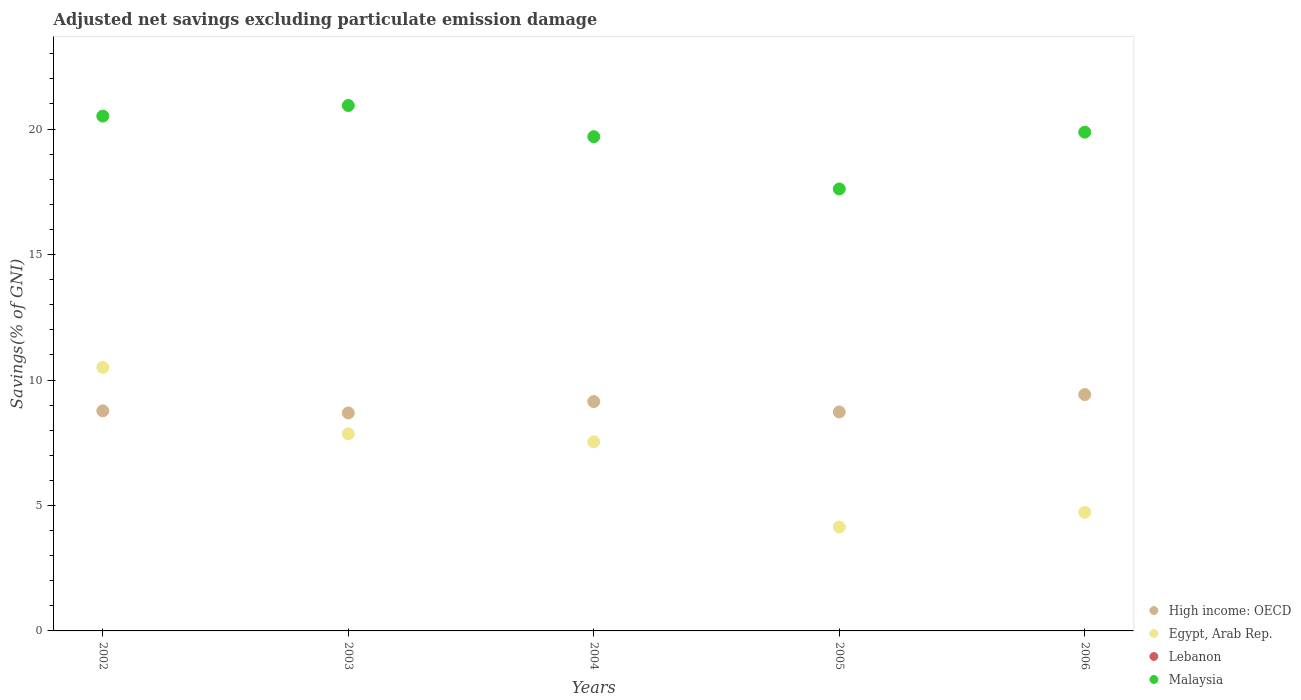How many different coloured dotlines are there?
Your response must be concise. 3. Is the number of dotlines equal to the number of legend labels?
Your answer should be very brief. No. What is the adjusted net savings in High income: OECD in 2006?
Offer a terse response. 9.42. Across all years, what is the maximum adjusted net savings in Malaysia?
Your answer should be compact. 20.94. Across all years, what is the minimum adjusted net savings in High income: OECD?
Give a very brief answer. 8.69. In which year was the adjusted net savings in High income: OECD maximum?
Offer a very short reply. 2006. What is the total adjusted net savings in Egypt, Arab Rep. in the graph?
Keep it short and to the point. 34.76. What is the difference between the adjusted net savings in Malaysia in 2004 and that in 2006?
Offer a very short reply. -0.18. What is the difference between the adjusted net savings in Egypt, Arab Rep. in 2003 and the adjusted net savings in High income: OECD in 2005?
Offer a very short reply. -0.87. What is the average adjusted net savings in High income: OECD per year?
Provide a short and direct response. 8.95. In the year 2006, what is the difference between the adjusted net savings in Egypt, Arab Rep. and adjusted net savings in Malaysia?
Offer a terse response. -15.15. What is the ratio of the adjusted net savings in Malaysia in 2005 to that in 2006?
Make the answer very short. 0.89. What is the difference between the highest and the second highest adjusted net savings in Malaysia?
Keep it short and to the point. 0.42. What is the difference between the highest and the lowest adjusted net savings in Malaysia?
Keep it short and to the point. 3.33. Is it the case that in every year, the sum of the adjusted net savings in Malaysia and adjusted net savings in High income: OECD  is greater than the adjusted net savings in Egypt, Arab Rep.?
Give a very brief answer. Yes. Does the adjusted net savings in Egypt, Arab Rep. monotonically increase over the years?
Provide a short and direct response. No. Is the adjusted net savings in Egypt, Arab Rep. strictly less than the adjusted net savings in High income: OECD over the years?
Offer a terse response. No. Are the values on the major ticks of Y-axis written in scientific E-notation?
Offer a terse response. No. Does the graph contain any zero values?
Ensure brevity in your answer.  Yes. How many legend labels are there?
Your answer should be very brief. 4. How are the legend labels stacked?
Provide a succinct answer. Vertical. What is the title of the graph?
Your response must be concise. Adjusted net savings excluding particulate emission damage. What is the label or title of the Y-axis?
Your response must be concise. Savings(% of GNI). What is the Savings(% of GNI) of High income: OECD in 2002?
Keep it short and to the point. 8.77. What is the Savings(% of GNI) in Egypt, Arab Rep. in 2002?
Make the answer very short. 10.5. What is the Savings(% of GNI) in Lebanon in 2002?
Give a very brief answer. 0. What is the Savings(% of GNI) in Malaysia in 2002?
Your response must be concise. 20.52. What is the Savings(% of GNI) of High income: OECD in 2003?
Make the answer very short. 8.69. What is the Savings(% of GNI) in Egypt, Arab Rep. in 2003?
Keep it short and to the point. 7.86. What is the Savings(% of GNI) in Malaysia in 2003?
Ensure brevity in your answer.  20.94. What is the Savings(% of GNI) of High income: OECD in 2004?
Give a very brief answer. 9.14. What is the Savings(% of GNI) of Egypt, Arab Rep. in 2004?
Your response must be concise. 7.54. What is the Savings(% of GNI) in Lebanon in 2004?
Provide a succinct answer. 0. What is the Savings(% of GNI) in Malaysia in 2004?
Keep it short and to the point. 19.7. What is the Savings(% of GNI) of High income: OECD in 2005?
Make the answer very short. 8.73. What is the Savings(% of GNI) in Egypt, Arab Rep. in 2005?
Ensure brevity in your answer.  4.14. What is the Savings(% of GNI) in Malaysia in 2005?
Offer a terse response. 17.61. What is the Savings(% of GNI) in High income: OECD in 2006?
Make the answer very short. 9.42. What is the Savings(% of GNI) of Egypt, Arab Rep. in 2006?
Keep it short and to the point. 4.73. What is the Savings(% of GNI) of Lebanon in 2006?
Your answer should be compact. 0. What is the Savings(% of GNI) of Malaysia in 2006?
Your answer should be compact. 19.88. Across all years, what is the maximum Savings(% of GNI) of High income: OECD?
Offer a terse response. 9.42. Across all years, what is the maximum Savings(% of GNI) in Egypt, Arab Rep.?
Ensure brevity in your answer.  10.5. Across all years, what is the maximum Savings(% of GNI) of Malaysia?
Provide a short and direct response. 20.94. Across all years, what is the minimum Savings(% of GNI) in High income: OECD?
Offer a terse response. 8.69. Across all years, what is the minimum Savings(% of GNI) of Egypt, Arab Rep.?
Give a very brief answer. 4.14. Across all years, what is the minimum Savings(% of GNI) in Malaysia?
Offer a terse response. 17.61. What is the total Savings(% of GNI) of High income: OECD in the graph?
Offer a terse response. 44.75. What is the total Savings(% of GNI) in Egypt, Arab Rep. in the graph?
Provide a short and direct response. 34.76. What is the total Savings(% of GNI) in Lebanon in the graph?
Ensure brevity in your answer.  0. What is the total Savings(% of GNI) of Malaysia in the graph?
Your answer should be very brief. 98.65. What is the difference between the Savings(% of GNI) in High income: OECD in 2002 and that in 2003?
Make the answer very short. 0.08. What is the difference between the Savings(% of GNI) of Egypt, Arab Rep. in 2002 and that in 2003?
Make the answer very short. 2.65. What is the difference between the Savings(% of GNI) of Malaysia in 2002 and that in 2003?
Keep it short and to the point. -0.42. What is the difference between the Savings(% of GNI) of High income: OECD in 2002 and that in 2004?
Ensure brevity in your answer.  -0.37. What is the difference between the Savings(% of GNI) of Egypt, Arab Rep. in 2002 and that in 2004?
Give a very brief answer. 2.97. What is the difference between the Savings(% of GNI) of Malaysia in 2002 and that in 2004?
Offer a terse response. 0.82. What is the difference between the Savings(% of GNI) of High income: OECD in 2002 and that in 2005?
Your response must be concise. 0.04. What is the difference between the Savings(% of GNI) of Egypt, Arab Rep. in 2002 and that in 2005?
Offer a very short reply. 6.36. What is the difference between the Savings(% of GNI) in Malaysia in 2002 and that in 2005?
Your response must be concise. 2.9. What is the difference between the Savings(% of GNI) in High income: OECD in 2002 and that in 2006?
Your answer should be compact. -0.65. What is the difference between the Savings(% of GNI) in Egypt, Arab Rep. in 2002 and that in 2006?
Your response must be concise. 5.77. What is the difference between the Savings(% of GNI) of Malaysia in 2002 and that in 2006?
Keep it short and to the point. 0.64. What is the difference between the Savings(% of GNI) of High income: OECD in 2003 and that in 2004?
Your response must be concise. -0.45. What is the difference between the Savings(% of GNI) of Egypt, Arab Rep. in 2003 and that in 2004?
Keep it short and to the point. 0.32. What is the difference between the Savings(% of GNI) in Malaysia in 2003 and that in 2004?
Offer a terse response. 1.24. What is the difference between the Savings(% of GNI) in High income: OECD in 2003 and that in 2005?
Your response must be concise. -0.04. What is the difference between the Savings(% of GNI) of Egypt, Arab Rep. in 2003 and that in 2005?
Offer a very short reply. 3.72. What is the difference between the Savings(% of GNI) in Malaysia in 2003 and that in 2005?
Offer a terse response. 3.33. What is the difference between the Savings(% of GNI) of High income: OECD in 2003 and that in 2006?
Provide a succinct answer. -0.73. What is the difference between the Savings(% of GNI) of Egypt, Arab Rep. in 2003 and that in 2006?
Provide a short and direct response. 3.13. What is the difference between the Savings(% of GNI) in Malaysia in 2003 and that in 2006?
Provide a succinct answer. 1.06. What is the difference between the Savings(% of GNI) of High income: OECD in 2004 and that in 2005?
Ensure brevity in your answer.  0.41. What is the difference between the Savings(% of GNI) of Egypt, Arab Rep. in 2004 and that in 2005?
Keep it short and to the point. 3.4. What is the difference between the Savings(% of GNI) in Malaysia in 2004 and that in 2005?
Your response must be concise. 2.08. What is the difference between the Savings(% of GNI) of High income: OECD in 2004 and that in 2006?
Offer a terse response. -0.28. What is the difference between the Savings(% of GNI) in Egypt, Arab Rep. in 2004 and that in 2006?
Offer a very short reply. 2.81. What is the difference between the Savings(% of GNI) of Malaysia in 2004 and that in 2006?
Provide a succinct answer. -0.18. What is the difference between the Savings(% of GNI) of High income: OECD in 2005 and that in 2006?
Provide a succinct answer. -0.69. What is the difference between the Savings(% of GNI) in Egypt, Arab Rep. in 2005 and that in 2006?
Keep it short and to the point. -0.59. What is the difference between the Savings(% of GNI) of Malaysia in 2005 and that in 2006?
Make the answer very short. -2.26. What is the difference between the Savings(% of GNI) in High income: OECD in 2002 and the Savings(% of GNI) in Egypt, Arab Rep. in 2003?
Offer a very short reply. 0.91. What is the difference between the Savings(% of GNI) of High income: OECD in 2002 and the Savings(% of GNI) of Malaysia in 2003?
Make the answer very short. -12.17. What is the difference between the Savings(% of GNI) in Egypt, Arab Rep. in 2002 and the Savings(% of GNI) in Malaysia in 2003?
Offer a terse response. -10.44. What is the difference between the Savings(% of GNI) of High income: OECD in 2002 and the Savings(% of GNI) of Egypt, Arab Rep. in 2004?
Offer a terse response. 1.23. What is the difference between the Savings(% of GNI) in High income: OECD in 2002 and the Savings(% of GNI) in Malaysia in 2004?
Offer a terse response. -10.93. What is the difference between the Savings(% of GNI) of Egypt, Arab Rep. in 2002 and the Savings(% of GNI) of Malaysia in 2004?
Ensure brevity in your answer.  -9.19. What is the difference between the Savings(% of GNI) in High income: OECD in 2002 and the Savings(% of GNI) in Egypt, Arab Rep. in 2005?
Give a very brief answer. 4.63. What is the difference between the Savings(% of GNI) in High income: OECD in 2002 and the Savings(% of GNI) in Malaysia in 2005?
Your answer should be very brief. -8.84. What is the difference between the Savings(% of GNI) of Egypt, Arab Rep. in 2002 and the Savings(% of GNI) of Malaysia in 2005?
Your response must be concise. -7.11. What is the difference between the Savings(% of GNI) of High income: OECD in 2002 and the Savings(% of GNI) of Egypt, Arab Rep. in 2006?
Offer a terse response. 4.04. What is the difference between the Savings(% of GNI) in High income: OECD in 2002 and the Savings(% of GNI) in Malaysia in 2006?
Your response must be concise. -11.11. What is the difference between the Savings(% of GNI) of Egypt, Arab Rep. in 2002 and the Savings(% of GNI) of Malaysia in 2006?
Provide a short and direct response. -9.38. What is the difference between the Savings(% of GNI) of High income: OECD in 2003 and the Savings(% of GNI) of Egypt, Arab Rep. in 2004?
Your response must be concise. 1.15. What is the difference between the Savings(% of GNI) in High income: OECD in 2003 and the Savings(% of GNI) in Malaysia in 2004?
Your answer should be compact. -11.01. What is the difference between the Savings(% of GNI) in Egypt, Arab Rep. in 2003 and the Savings(% of GNI) in Malaysia in 2004?
Offer a very short reply. -11.84. What is the difference between the Savings(% of GNI) of High income: OECD in 2003 and the Savings(% of GNI) of Egypt, Arab Rep. in 2005?
Ensure brevity in your answer.  4.55. What is the difference between the Savings(% of GNI) of High income: OECD in 2003 and the Savings(% of GNI) of Malaysia in 2005?
Offer a very short reply. -8.93. What is the difference between the Savings(% of GNI) in Egypt, Arab Rep. in 2003 and the Savings(% of GNI) in Malaysia in 2005?
Offer a very short reply. -9.76. What is the difference between the Savings(% of GNI) in High income: OECD in 2003 and the Savings(% of GNI) in Egypt, Arab Rep. in 2006?
Your answer should be compact. 3.96. What is the difference between the Savings(% of GNI) of High income: OECD in 2003 and the Savings(% of GNI) of Malaysia in 2006?
Provide a short and direct response. -11.19. What is the difference between the Savings(% of GNI) in Egypt, Arab Rep. in 2003 and the Savings(% of GNI) in Malaysia in 2006?
Keep it short and to the point. -12.02. What is the difference between the Savings(% of GNI) of High income: OECD in 2004 and the Savings(% of GNI) of Egypt, Arab Rep. in 2005?
Make the answer very short. 5. What is the difference between the Savings(% of GNI) of High income: OECD in 2004 and the Savings(% of GNI) of Malaysia in 2005?
Ensure brevity in your answer.  -8.47. What is the difference between the Savings(% of GNI) in Egypt, Arab Rep. in 2004 and the Savings(% of GNI) in Malaysia in 2005?
Keep it short and to the point. -10.08. What is the difference between the Savings(% of GNI) of High income: OECD in 2004 and the Savings(% of GNI) of Egypt, Arab Rep. in 2006?
Provide a short and direct response. 4.41. What is the difference between the Savings(% of GNI) in High income: OECD in 2004 and the Savings(% of GNI) in Malaysia in 2006?
Make the answer very short. -10.74. What is the difference between the Savings(% of GNI) in Egypt, Arab Rep. in 2004 and the Savings(% of GNI) in Malaysia in 2006?
Provide a succinct answer. -12.34. What is the difference between the Savings(% of GNI) of High income: OECD in 2005 and the Savings(% of GNI) of Egypt, Arab Rep. in 2006?
Offer a terse response. 4. What is the difference between the Savings(% of GNI) in High income: OECD in 2005 and the Savings(% of GNI) in Malaysia in 2006?
Keep it short and to the point. -11.15. What is the difference between the Savings(% of GNI) of Egypt, Arab Rep. in 2005 and the Savings(% of GNI) of Malaysia in 2006?
Give a very brief answer. -15.74. What is the average Savings(% of GNI) in High income: OECD per year?
Offer a very short reply. 8.95. What is the average Savings(% of GNI) of Egypt, Arab Rep. per year?
Make the answer very short. 6.95. What is the average Savings(% of GNI) of Lebanon per year?
Offer a terse response. 0. What is the average Savings(% of GNI) in Malaysia per year?
Provide a succinct answer. 19.73. In the year 2002, what is the difference between the Savings(% of GNI) of High income: OECD and Savings(% of GNI) of Egypt, Arab Rep.?
Provide a succinct answer. -1.73. In the year 2002, what is the difference between the Savings(% of GNI) of High income: OECD and Savings(% of GNI) of Malaysia?
Ensure brevity in your answer.  -11.75. In the year 2002, what is the difference between the Savings(% of GNI) in Egypt, Arab Rep. and Savings(% of GNI) in Malaysia?
Offer a terse response. -10.02. In the year 2003, what is the difference between the Savings(% of GNI) in High income: OECD and Savings(% of GNI) in Egypt, Arab Rep.?
Your answer should be compact. 0.83. In the year 2003, what is the difference between the Savings(% of GNI) in High income: OECD and Savings(% of GNI) in Malaysia?
Offer a very short reply. -12.25. In the year 2003, what is the difference between the Savings(% of GNI) of Egypt, Arab Rep. and Savings(% of GNI) of Malaysia?
Offer a terse response. -13.08. In the year 2004, what is the difference between the Savings(% of GNI) of High income: OECD and Savings(% of GNI) of Egypt, Arab Rep.?
Your answer should be very brief. 1.61. In the year 2004, what is the difference between the Savings(% of GNI) in High income: OECD and Savings(% of GNI) in Malaysia?
Offer a very short reply. -10.56. In the year 2004, what is the difference between the Savings(% of GNI) of Egypt, Arab Rep. and Savings(% of GNI) of Malaysia?
Offer a very short reply. -12.16. In the year 2005, what is the difference between the Savings(% of GNI) of High income: OECD and Savings(% of GNI) of Egypt, Arab Rep.?
Your response must be concise. 4.59. In the year 2005, what is the difference between the Savings(% of GNI) in High income: OECD and Savings(% of GNI) in Malaysia?
Keep it short and to the point. -8.89. In the year 2005, what is the difference between the Savings(% of GNI) in Egypt, Arab Rep. and Savings(% of GNI) in Malaysia?
Offer a very short reply. -13.47. In the year 2006, what is the difference between the Savings(% of GNI) of High income: OECD and Savings(% of GNI) of Egypt, Arab Rep.?
Offer a terse response. 4.69. In the year 2006, what is the difference between the Savings(% of GNI) in High income: OECD and Savings(% of GNI) in Malaysia?
Ensure brevity in your answer.  -10.46. In the year 2006, what is the difference between the Savings(% of GNI) in Egypt, Arab Rep. and Savings(% of GNI) in Malaysia?
Make the answer very short. -15.15. What is the ratio of the Savings(% of GNI) in High income: OECD in 2002 to that in 2003?
Offer a terse response. 1.01. What is the ratio of the Savings(% of GNI) in Egypt, Arab Rep. in 2002 to that in 2003?
Your answer should be compact. 1.34. What is the ratio of the Savings(% of GNI) in Malaysia in 2002 to that in 2003?
Your response must be concise. 0.98. What is the ratio of the Savings(% of GNI) in High income: OECD in 2002 to that in 2004?
Give a very brief answer. 0.96. What is the ratio of the Savings(% of GNI) of Egypt, Arab Rep. in 2002 to that in 2004?
Keep it short and to the point. 1.39. What is the ratio of the Savings(% of GNI) in Malaysia in 2002 to that in 2004?
Give a very brief answer. 1.04. What is the ratio of the Savings(% of GNI) of Egypt, Arab Rep. in 2002 to that in 2005?
Ensure brevity in your answer.  2.54. What is the ratio of the Savings(% of GNI) in Malaysia in 2002 to that in 2005?
Provide a succinct answer. 1.16. What is the ratio of the Savings(% of GNI) of High income: OECD in 2002 to that in 2006?
Offer a very short reply. 0.93. What is the ratio of the Savings(% of GNI) in Egypt, Arab Rep. in 2002 to that in 2006?
Your answer should be very brief. 2.22. What is the ratio of the Savings(% of GNI) in Malaysia in 2002 to that in 2006?
Offer a very short reply. 1.03. What is the ratio of the Savings(% of GNI) in High income: OECD in 2003 to that in 2004?
Your answer should be compact. 0.95. What is the ratio of the Savings(% of GNI) of Egypt, Arab Rep. in 2003 to that in 2004?
Make the answer very short. 1.04. What is the ratio of the Savings(% of GNI) of Malaysia in 2003 to that in 2004?
Keep it short and to the point. 1.06. What is the ratio of the Savings(% of GNI) of Egypt, Arab Rep. in 2003 to that in 2005?
Offer a terse response. 1.9. What is the ratio of the Savings(% of GNI) in Malaysia in 2003 to that in 2005?
Provide a short and direct response. 1.19. What is the ratio of the Savings(% of GNI) of High income: OECD in 2003 to that in 2006?
Your answer should be compact. 0.92. What is the ratio of the Savings(% of GNI) in Egypt, Arab Rep. in 2003 to that in 2006?
Provide a short and direct response. 1.66. What is the ratio of the Savings(% of GNI) in Malaysia in 2003 to that in 2006?
Your answer should be very brief. 1.05. What is the ratio of the Savings(% of GNI) in High income: OECD in 2004 to that in 2005?
Ensure brevity in your answer.  1.05. What is the ratio of the Savings(% of GNI) of Egypt, Arab Rep. in 2004 to that in 2005?
Keep it short and to the point. 1.82. What is the ratio of the Savings(% of GNI) in Malaysia in 2004 to that in 2005?
Your answer should be compact. 1.12. What is the ratio of the Savings(% of GNI) in High income: OECD in 2004 to that in 2006?
Your answer should be compact. 0.97. What is the ratio of the Savings(% of GNI) of Egypt, Arab Rep. in 2004 to that in 2006?
Your answer should be very brief. 1.59. What is the ratio of the Savings(% of GNI) in Malaysia in 2004 to that in 2006?
Your answer should be very brief. 0.99. What is the ratio of the Savings(% of GNI) of High income: OECD in 2005 to that in 2006?
Your answer should be compact. 0.93. What is the ratio of the Savings(% of GNI) in Egypt, Arab Rep. in 2005 to that in 2006?
Your answer should be very brief. 0.88. What is the ratio of the Savings(% of GNI) in Malaysia in 2005 to that in 2006?
Provide a succinct answer. 0.89. What is the difference between the highest and the second highest Savings(% of GNI) of High income: OECD?
Your answer should be very brief. 0.28. What is the difference between the highest and the second highest Savings(% of GNI) in Egypt, Arab Rep.?
Give a very brief answer. 2.65. What is the difference between the highest and the second highest Savings(% of GNI) of Malaysia?
Your answer should be very brief. 0.42. What is the difference between the highest and the lowest Savings(% of GNI) in High income: OECD?
Provide a short and direct response. 0.73. What is the difference between the highest and the lowest Savings(% of GNI) of Egypt, Arab Rep.?
Keep it short and to the point. 6.36. What is the difference between the highest and the lowest Savings(% of GNI) of Malaysia?
Your response must be concise. 3.33. 